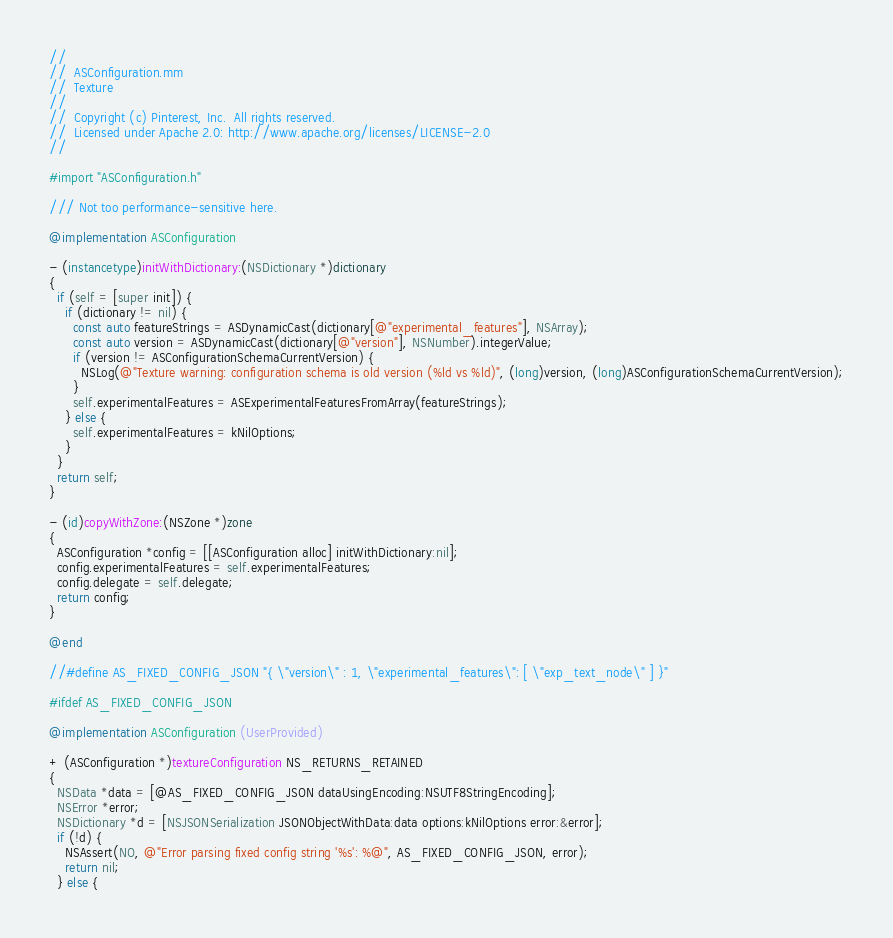<code> <loc_0><loc_0><loc_500><loc_500><_ObjectiveC_>//
//  ASConfiguration.mm
//  Texture
//
//  Copyright (c) Pinterest, Inc.  All rights reserved.
//  Licensed under Apache 2.0: http://www.apache.org/licenses/LICENSE-2.0
//

#import "ASConfiguration.h"

/// Not too performance-sensitive here.

@implementation ASConfiguration

- (instancetype)initWithDictionary:(NSDictionary *)dictionary
{
  if (self = [super init]) {
    if (dictionary != nil) {
      const auto featureStrings = ASDynamicCast(dictionary[@"experimental_features"], NSArray);
      const auto version = ASDynamicCast(dictionary[@"version"], NSNumber).integerValue;
      if (version != ASConfigurationSchemaCurrentVersion) {
        NSLog(@"Texture warning: configuration schema is old version (%ld vs %ld)", (long)version, (long)ASConfigurationSchemaCurrentVersion);
      }
      self.experimentalFeatures = ASExperimentalFeaturesFromArray(featureStrings);
    } else {
      self.experimentalFeatures = kNilOptions;
    }
  }
  return self;
}

- (id)copyWithZone:(NSZone *)zone
{
  ASConfiguration *config = [[ASConfiguration alloc] initWithDictionary:nil];
  config.experimentalFeatures = self.experimentalFeatures;
  config.delegate = self.delegate;
  return config;
}

@end

//#define AS_FIXED_CONFIG_JSON "{ \"version\" : 1, \"experimental_features\": [ \"exp_text_node\" ] }"

#ifdef AS_FIXED_CONFIG_JSON

@implementation ASConfiguration (UserProvided)

+ (ASConfiguration *)textureConfiguration NS_RETURNS_RETAINED
{
  NSData *data = [@AS_FIXED_CONFIG_JSON dataUsingEncoding:NSUTF8StringEncoding];
  NSError *error;
  NSDictionary *d = [NSJSONSerialization JSONObjectWithData:data options:kNilOptions error:&error];
  if (!d) {
    NSAssert(NO, @"Error parsing fixed config string '%s': %@", AS_FIXED_CONFIG_JSON, error);
    return nil;
  } else {</code> 